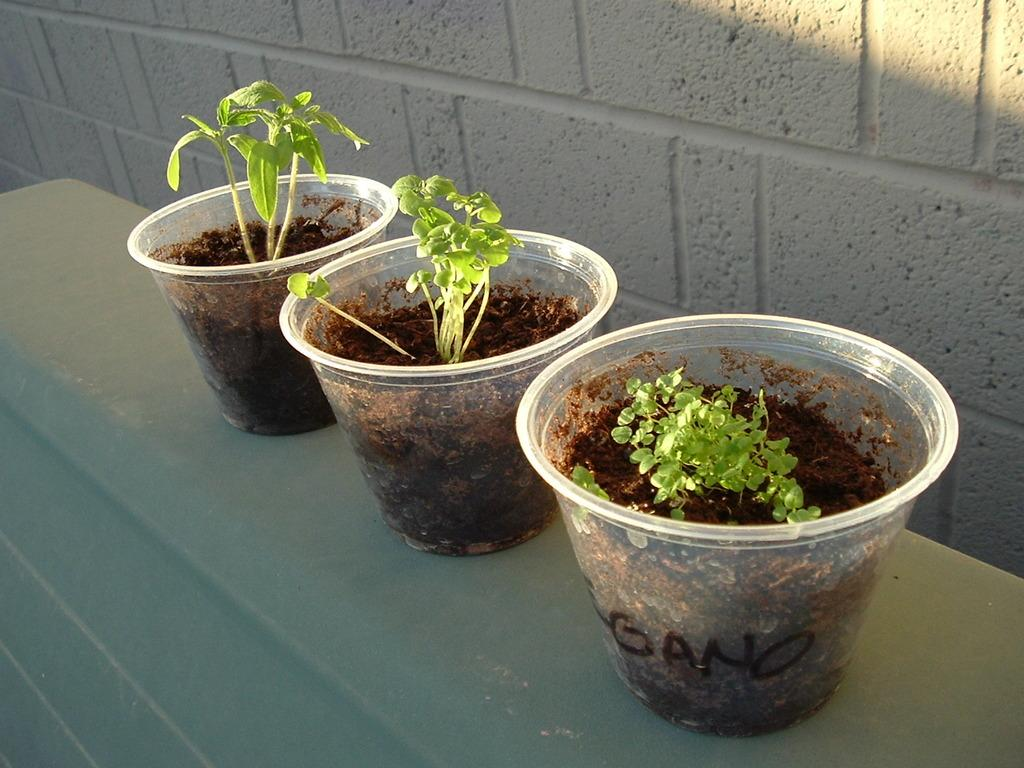How many house plants are on the table in the image? There are three house plants on the table in the image. What can be seen in the background of the image? There is a wall visible in the background of the image. What type of rock is visible on the moon in the image? There is no rock or moon present in the image; it only features three house plants on a table and a wall in the background. 